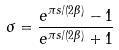<formula> <loc_0><loc_0><loc_500><loc_500>\sigma = \frac { e ^ { \pi s / ( 2 \beta ) } - 1 } { e ^ { \pi s / ( 2 \beta ) } + 1 }</formula> 